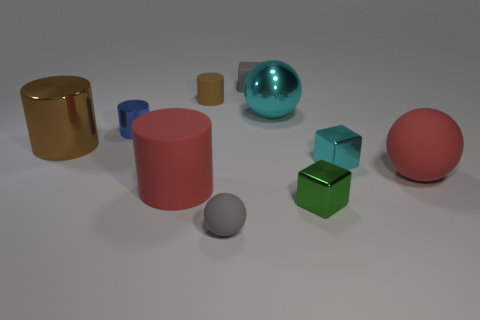The tiny metallic object that is both behind the red rubber cylinder and on the right side of the cyan shiny ball has what shape?
Provide a short and direct response. Cube. Are there any red cylinders of the same size as the metallic sphere?
Give a very brief answer. Yes. What number of objects are objects behind the gray matte sphere or tiny shiny cylinders?
Offer a terse response. 9. Is the material of the red ball the same as the tiny gray object behind the tiny brown rubber cylinder?
Ensure brevity in your answer.  Yes. How many other objects are there of the same shape as the large brown object?
Give a very brief answer. 3. What number of things are red things in front of the large brown shiny cylinder or tiny metal blocks right of the tiny green thing?
Make the answer very short. 3. How many other things are there of the same color as the tiny matte cube?
Provide a short and direct response. 1. Is the number of gray spheres that are on the left side of the gray rubber ball less than the number of cubes behind the blue metallic thing?
Keep it short and to the point. Yes. What number of big brown rubber cylinders are there?
Your response must be concise. 0. Are there any other things that are made of the same material as the tiny blue thing?
Provide a succinct answer. Yes. 